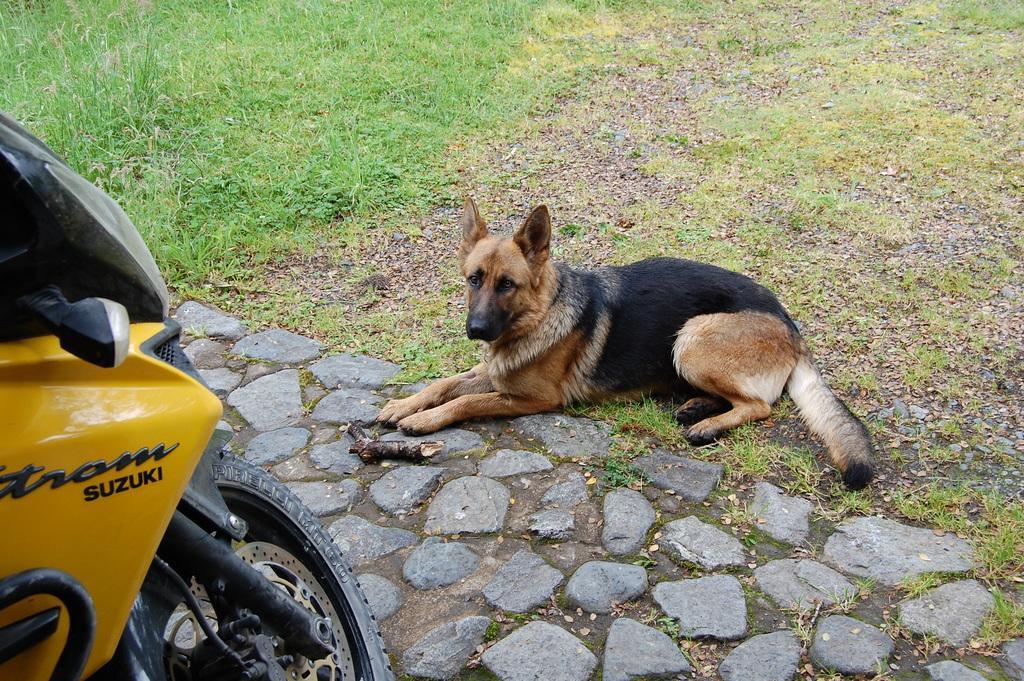In one or two sentences, can you explain what this image depicts? On the left side of the image we can see a bike with some text on it. In the center of the image we can see stones and one dog. In front of a dog, we can see one object. In the background, we can see the grass. 